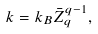<formula> <loc_0><loc_0><loc_500><loc_500>k = k _ { B } \bar { Z } _ { q } ^ { q - 1 } ,</formula> 